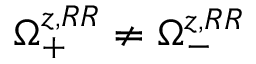Convert formula to latex. <formula><loc_0><loc_0><loc_500><loc_500>\Omega _ { + } ^ { z , R R } \neq \Omega _ { - } ^ { z , R R }</formula> 